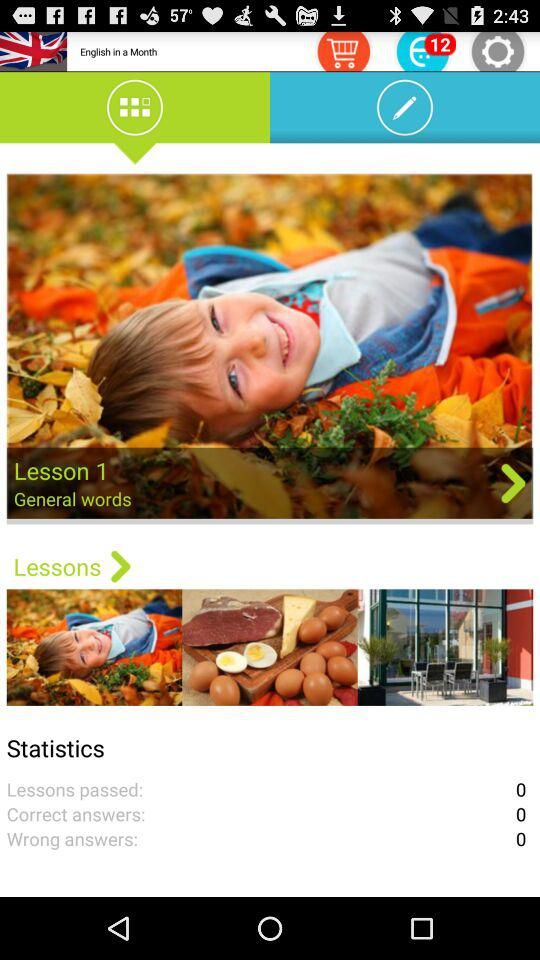What is the count for lessons passed? The count is 0. 